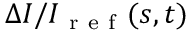Convert formula to latex. <formula><loc_0><loc_0><loc_500><loc_500>\Delta I / I _ { r e f } ( s , t )</formula> 